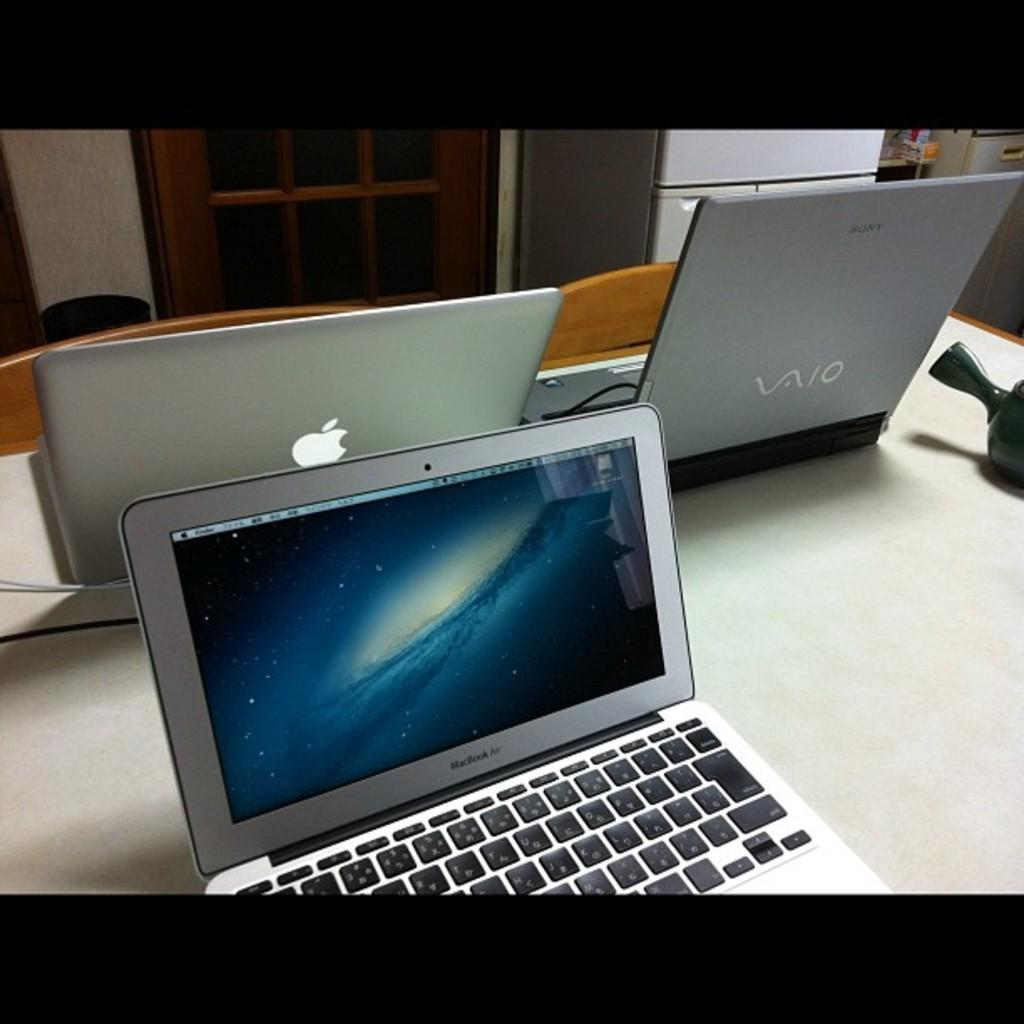<image>
Render a clear and concise summary of the photo. A Macbook air, a Vaio and an Apple laptop are sitting on a table. 